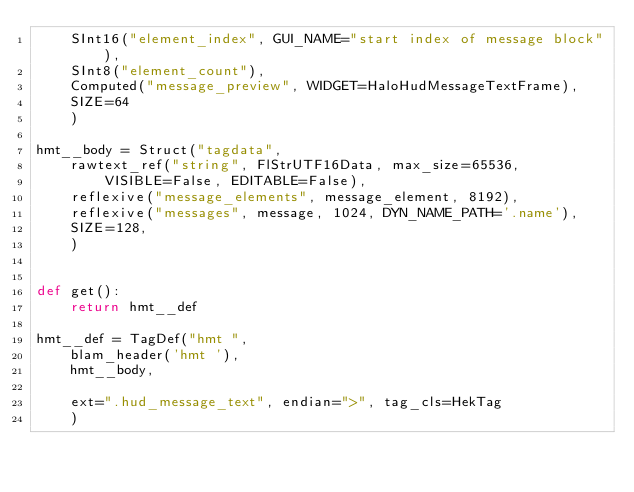<code> <loc_0><loc_0><loc_500><loc_500><_Python_>    SInt16("element_index", GUI_NAME="start index of message block"),
    SInt8("element_count"),
    Computed("message_preview", WIDGET=HaloHudMessageTextFrame),
    SIZE=64
    )

hmt__body = Struct("tagdata",
    rawtext_ref("string", FlStrUTF16Data, max_size=65536,
        VISIBLE=False, EDITABLE=False),
    reflexive("message_elements", message_element, 8192),
    reflexive("messages", message, 1024, DYN_NAME_PATH='.name'),
    SIZE=128,
    )


def get():
    return hmt__def

hmt__def = TagDef("hmt ",
    blam_header('hmt '),
    hmt__body,

    ext=".hud_message_text", endian=">", tag_cls=HekTag
    )
</code> 